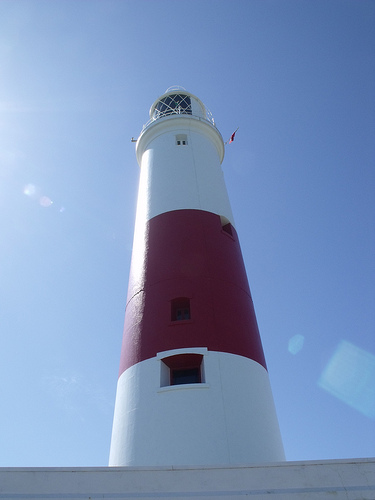<image>
Can you confirm if the sky is behind the light house? Yes. From this viewpoint, the sky is positioned behind the light house, with the light house partially or fully occluding the sky. 